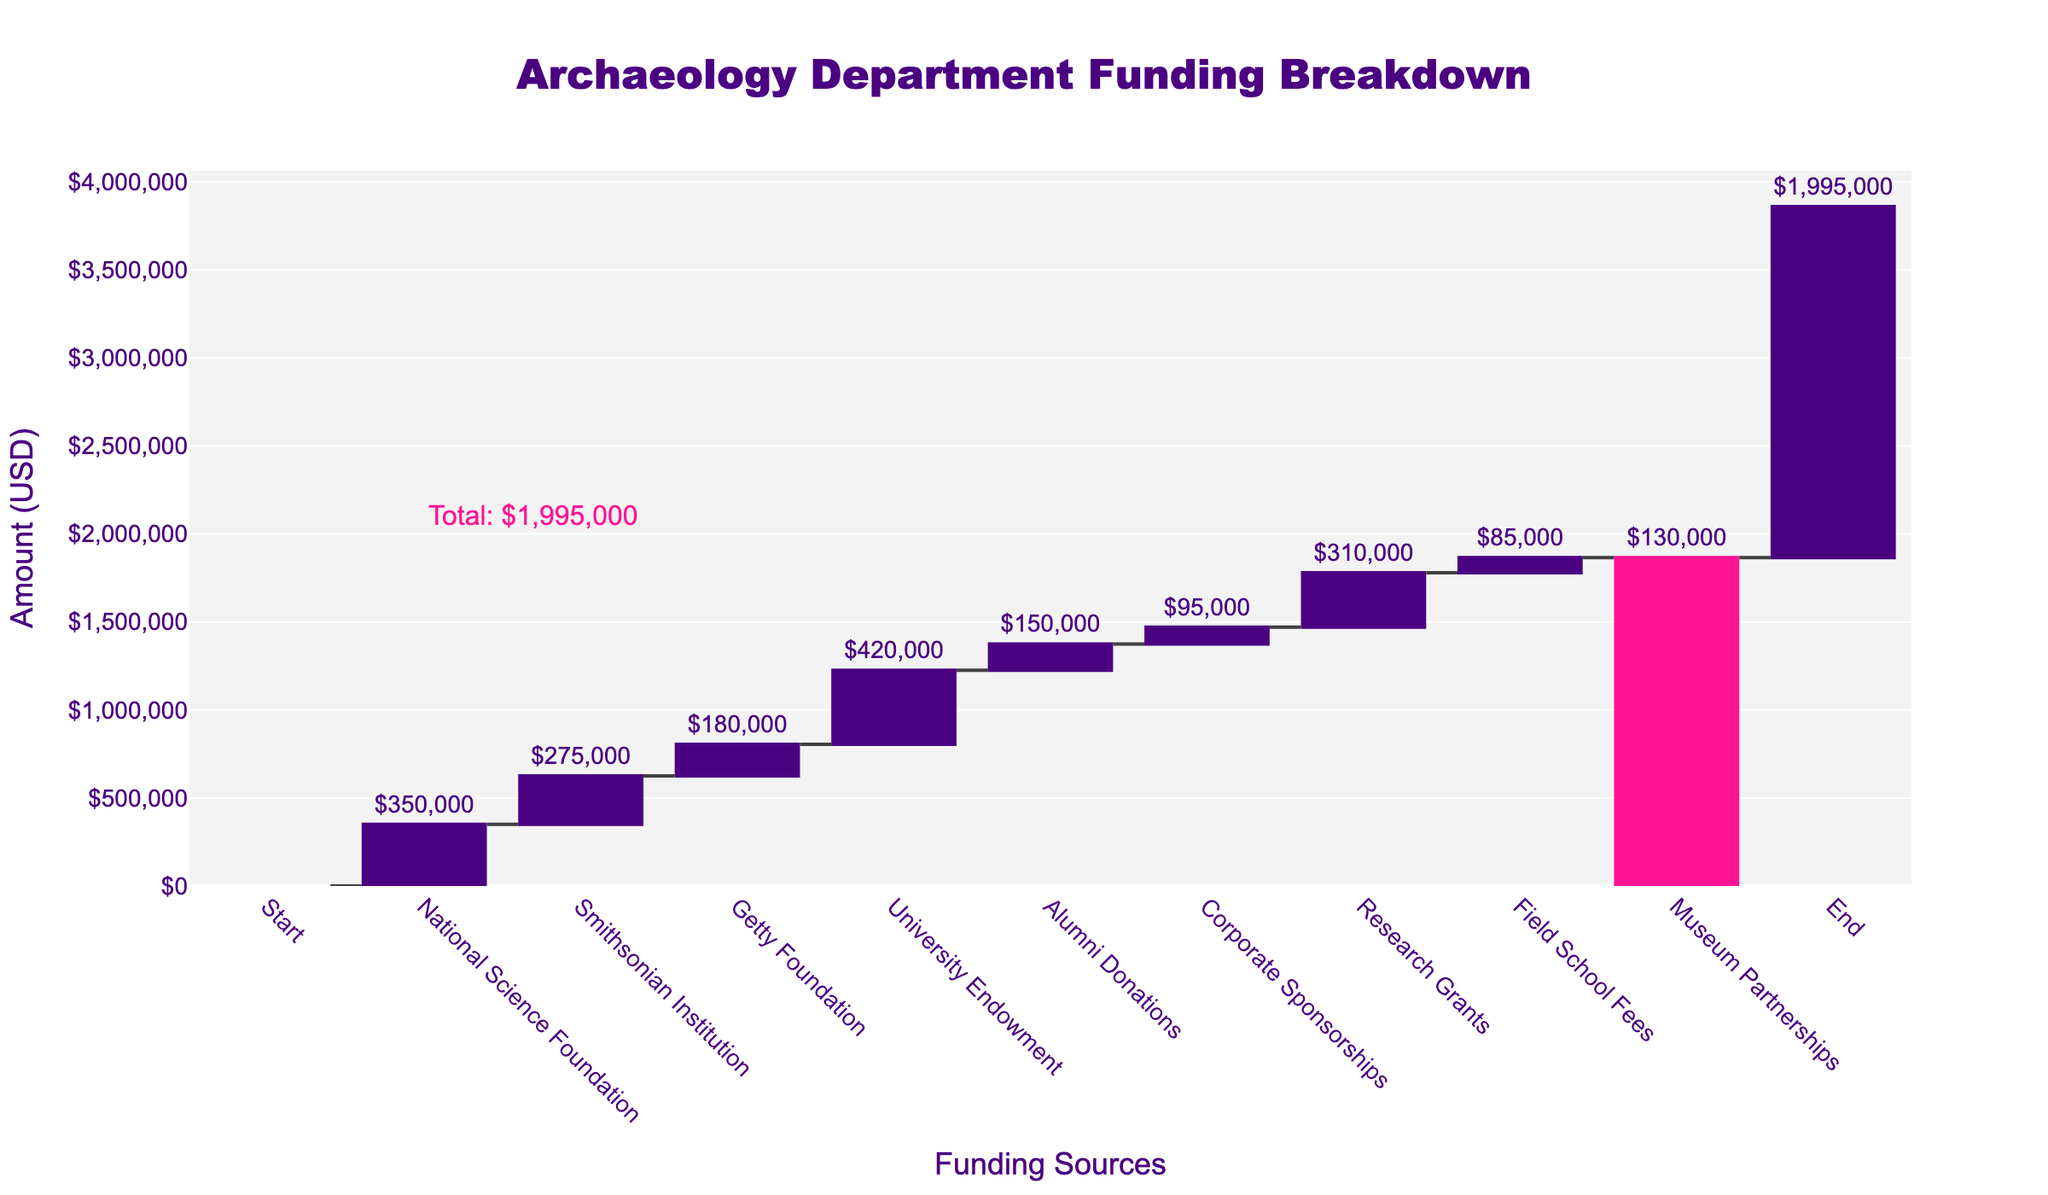How many funding categories are highlighted in the chart? There are individual values denoted for each funding source category listed in the chart. By counting these distinct categories, we see a total of 9 funding sources plus the start and end.
Answer: 9 What is the title of the chart? The title is typically found at the top center of the chart and is displayed in a larger and bolder font. In this chart, the title is "Archaeology Department Funding Breakdown."
Answer: Archaeology Department Funding Breakdown Which funding source contributed the highest amount? Observing the individual bars representing each funding source on the chart, the one with the highest value is "University Endowment" with $420,000.
Answer: University Endowment What is the cumulative value at the final funding category? The final value of the "End" category is the cumulative total of all contributing funding sources combined. The final amount shown is $1,995,000.
Answer: $1,995,000 How much more did the Research Grants contribute compared to Corporate Sponsorships? To find this, observe the values for "Research Grants" and "Corporate Sponsorships." The difference is calculated as $310,000 - $95,000 = $215,000.
Answer: $215,000 What's the difference between the contribution of the Smithsonian Institution and the Getty Foundation? Subtract the Getty Foundation's contribution from that of the Smithsonian Institution: $275,000 - $180,000 = $95,000.
Answer: $95,000 Which funding sources contributed more than $200,000 each? By identifying the values associated with each funding source, the ones that contribute more than $200,000 are "National Science Foundation," "Smithsonian Institution," and "University Endowment."
Answer: National Science Foundation, Smithsonian Institution, University Endowment Is the contribution from Alumni Donations greater or lesser than from Field School Fees? Observing the values on the chart, we compare $150,000 (Alumni Donations) with $85,000 (Field School Fees) and find that Alumni Donations contribute more.
Answer: Greater What are the total contributions from the Smithsonian Institution and Museum Partnerships combined? Adding the values from these two funding sources: $275,000 (Smithsonian Institution) + $130,000 (Museum Partnerships) = $405,000.
Answer: $405,000 What is the average contribution of all funding sources excluding the start and end points? First, sum the contributions: $350,000 + $275,000 + $180,000 + $420,000 + $150,000 + $95,000 + $310,000 + $85,000 + $130,000 = $1,995,000. Divide this by 9 (the number of funding sources): $1,995,000 / 9 ≈ $221,666.67.
Answer: $221,667 